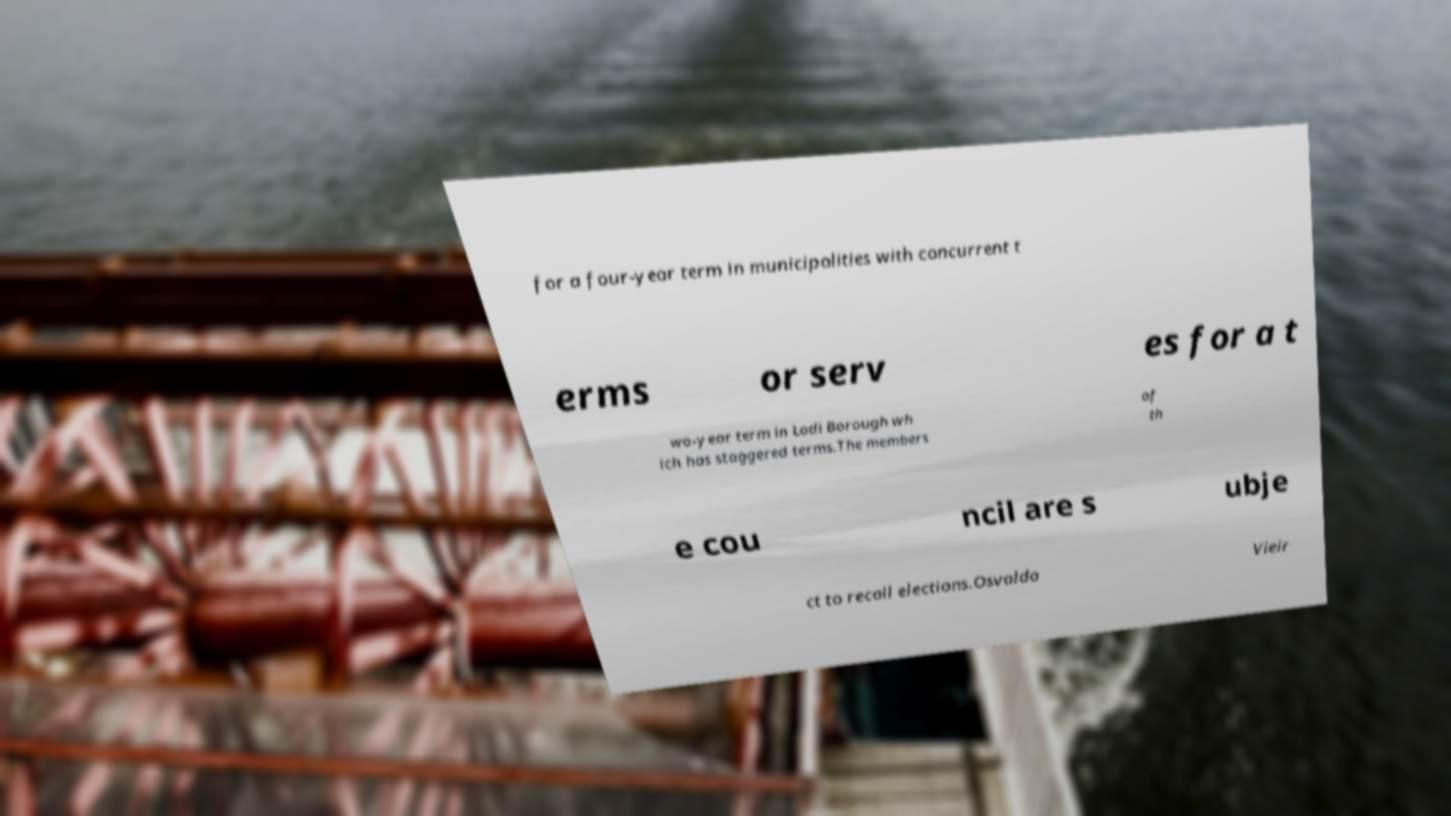For documentation purposes, I need the text within this image transcribed. Could you provide that? for a four-year term in municipalities with concurrent t erms or serv es for a t wo-year term in Lodi Borough wh ich has staggered terms.The members of th e cou ncil are s ubje ct to recall elections.Osvaldo Vieir 